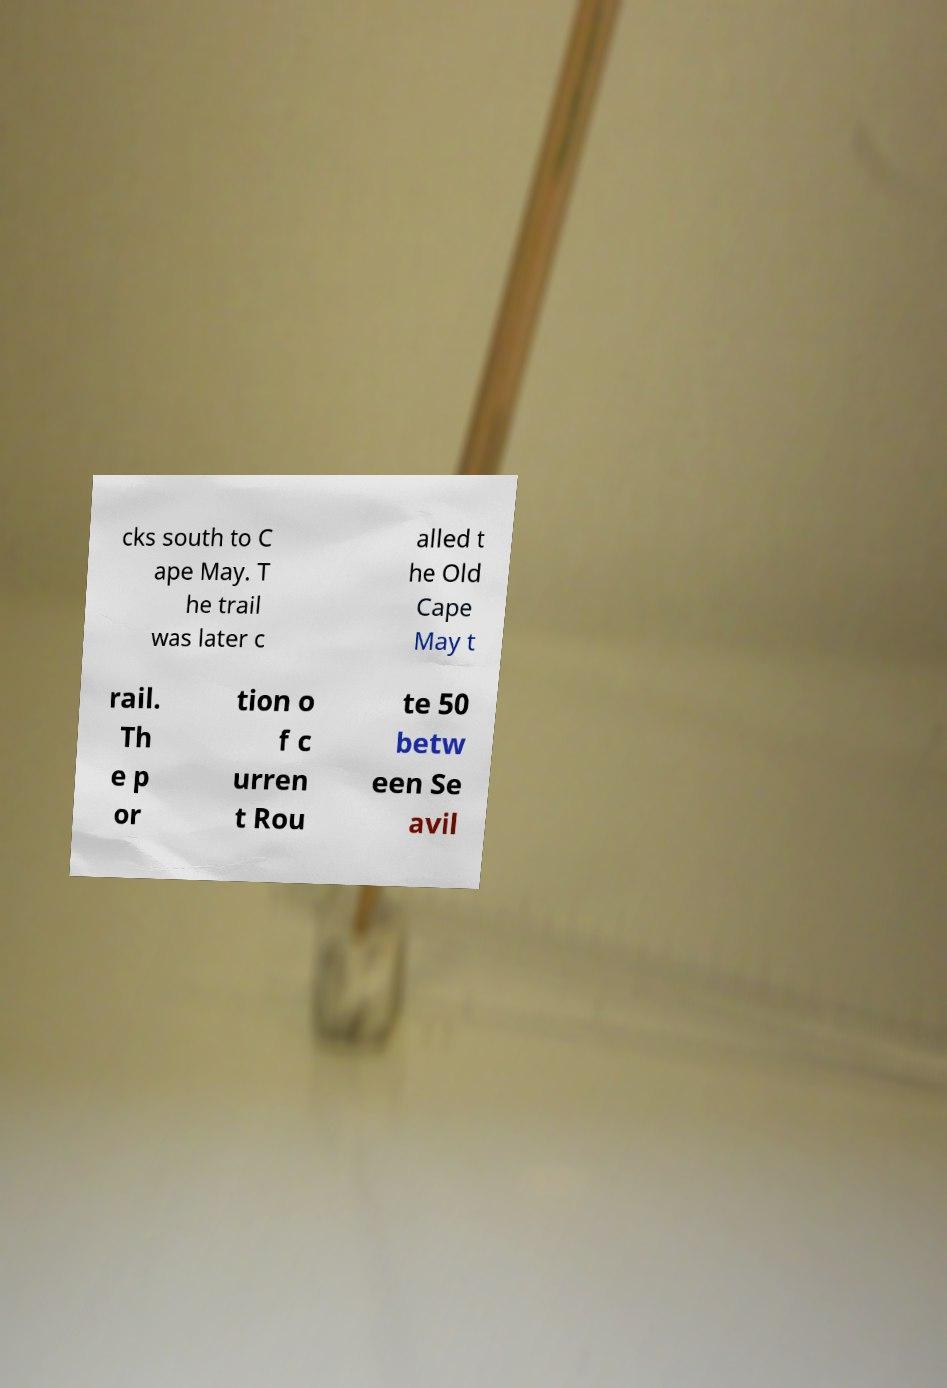There's text embedded in this image that I need extracted. Can you transcribe it verbatim? cks south to C ape May. T he trail was later c alled t he Old Cape May t rail. Th e p or tion o f c urren t Rou te 50 betw een Se avil 